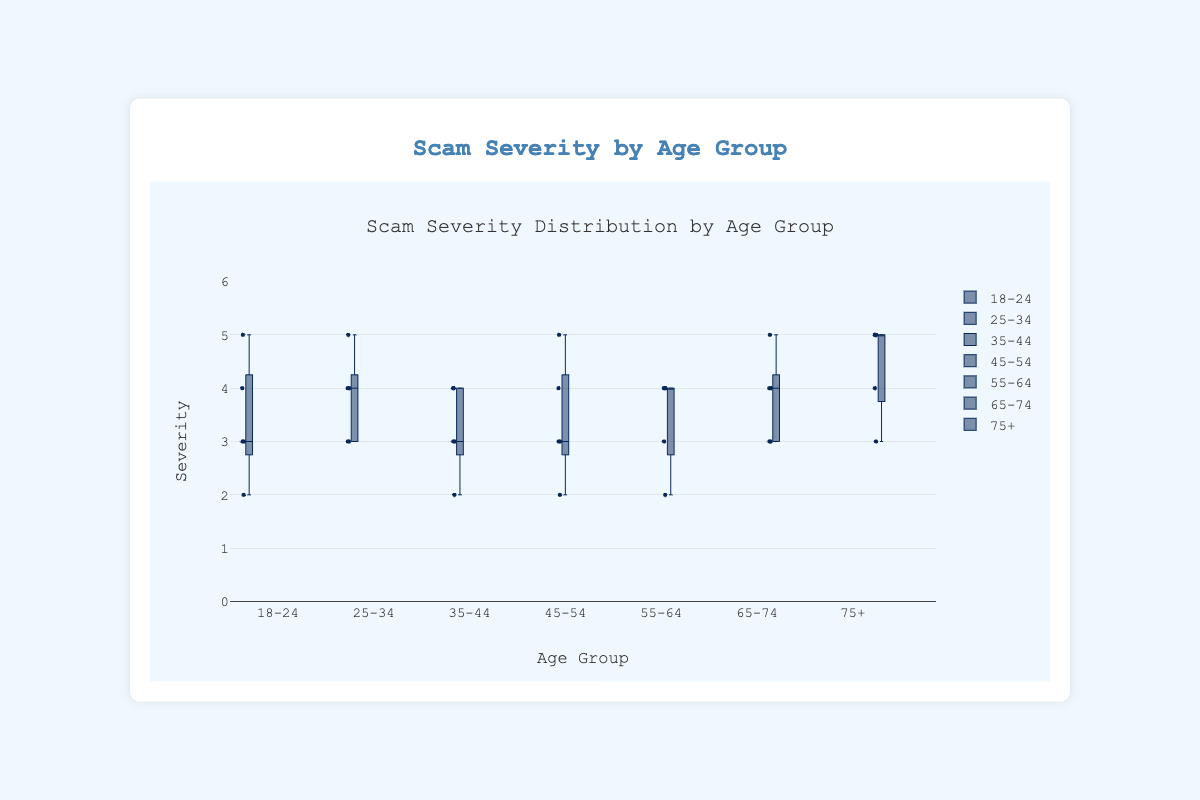What's the title of the box plot? The title of the box plot is located at the top of the figure and summarizes the main focus of the plot. From the information provided in the code, the title is "Scam Severity Distribution by Age Group."
Answer: Scam Severity Distribution by Age Group What does the y-axis represent? The y-axis of the box plot indicates the severity of scam incidents. The range on the y-axis is specified from 0 to 6, with the title clearly stating "Severity."
Answer: Severity Which age group has the widest range of scam severity values? To identify the age group with the widest range of scam severity values, observe the box plot's whiskers (lines extending from the boxes). The "18-24" age group has severity values ranging from 2 to 5, the least wide, and the "75+" age group has severity values ranging from around 3 to 5. However, the "65-74" and "75+" age groups seem to have a wider range. By close observation, the "75+" age group has the widest range as there are no data points below 3 and extends up to 5.
Answer: 75+ Which age group reports the highest median scam severity? The median is depicted by the line inside each box. By comparing the medians across all groups, the "75+" age group’s median is clearly at the 5 severity level, which is the highest among all the age groups.
Answer: 75+ What is the median severity value for the 25-34 age group? The median value for a box plot is the line inside the box. For the 25-34 age group, this line is at the severity value of 4.
Answer: 4 Between the age groups 35-44 and 45-54, which one has a higher median severity value? Compare the median lines (inside the boxes) for the age groups 35-44 and 45-54. The median severity for the 35-44 age group is 3, while for the 45-54 age group also it is 3. Both groups have the same median value.
Answer: Both are equal Which age group has the lowest reported severity incident? The lowest point on the y-axis for each group indicates the lowest reported severity incident. By examining the whiskers extending downward, the 35-44 and 45-54 age groups both have the lowest severity value of 2.
Answer: 35-44 and 45-54 Among the age groups under 55, which one reports the most severe incidents (severity = 5) most frequently? Observe the individual data points marked within each group. The 25-34 age group has more points at 5 compared to the other age groups below 55, implying frequent severe incidents (severity = 5).
Answer: 25-34 How does the variability in scam severity for the 55-64 age group compare with that of the 65-74 age group? The variability can be interpreted by looking at the spread of the box and the whiskers. The whiskers for 55-64 extend from 2 to 4, indicating less variability compared to the 65-74 group which extends from 3 to 5. Thus, the 65-74 group has more variability in scam severity.
Answer: More variable Which age groups have outliers, and where are they located? Outliers are the individual data points that fall outside the whiskers of the box plot. The plot indicates no specific 'floating' points outside the whiskers, so none of the age groups have distinct outliers.
Answer: None 